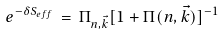<formula> <loc_0><loc_0><loc_500><loc_500>e ^ { - \delta S _ { e f f } } \, = \, \Pi _ { n , { \vec { k } } } [ 1 + \Pi ( n , { \vec { k } } ) ] ^ { - 1 } \,</formula> 